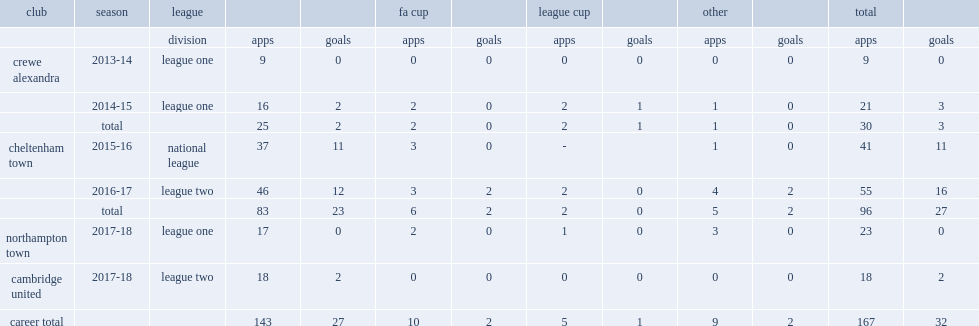Which league did billy waters move to cheltenham town for in the 2015-16 season? National league. 